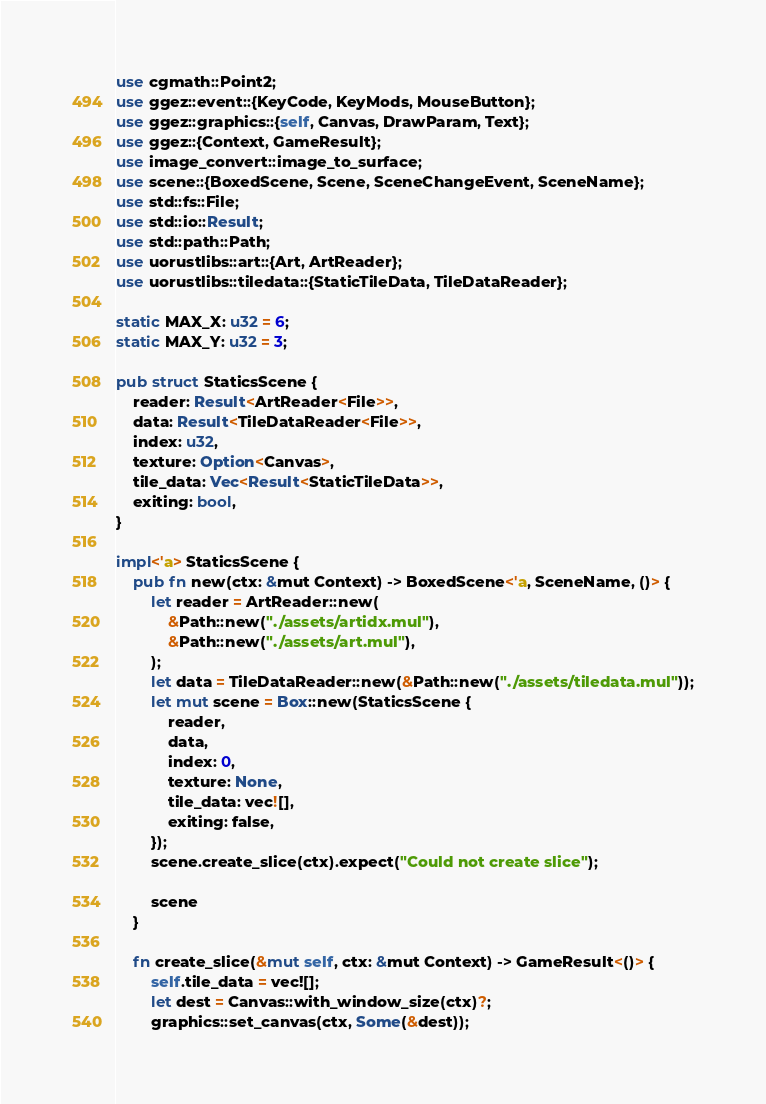<code> <loc_0><loc_0><loc_500><loc_500><_Rust_>use cgmath::Point2;
use ggez::event::{KeyCode, KeyMods, MouseButton};
use ggez::graphics::{self, Canvas, DrawParam, Text};
use ggez::{Context, GameResult};
use image_convert::image_to_surface;
use scene::{BoxedScene, Scene, SceneChangeEvent, SceneName};
use std::fs::File;
use std::io::Result;
use std::path::Path;
use uorustlibs::art::{Art, ArtReader};
use uorustlibs::tiledata::{StaticTileData, TileDataReader};

static MAX_X: u32 = 6;
static MAX_Y: u32 = 3;

pub struct StaticsScene {
    reader: Result<ArtReader<File>>,
    data: Result<TileDataReader<File>>,
    index: u32,
    texture: Option<Canvas>,
    tile_data: Vec<Result<StaticTileData>>,
    exiting: bool,
}

impl<'a> StaticsScene {
    pub fn new(ctx: &mut Context) -> BoxedScene<'a, SceneName, ()> {
        let reader = ArtReader::new(
            &Path::new("./assets/artidx.mul"),
            &Path::new("./assets/art.mul"),
        );
        let data = TileDataReader::new(&Path::new("./assets/tiledata.mul"));
        let mut scene = Box::new(StaticsScene {
            reader,
            data,
            index: 0,
            texture: None,
            tile_data: vec![],
            exiting: false,
        });
        scene.create_slice(ctx).expect("Could not create slice");

        scene
    }

    fn create_slice(&mut self, ctx: &mut Context) -> GameResult<()> {
        self.tile_data = vec![];
        let dest = Canvas::with_window_size(ctx)?;
        graphics::set_canvas(ctx, Some(&dest));</code> 